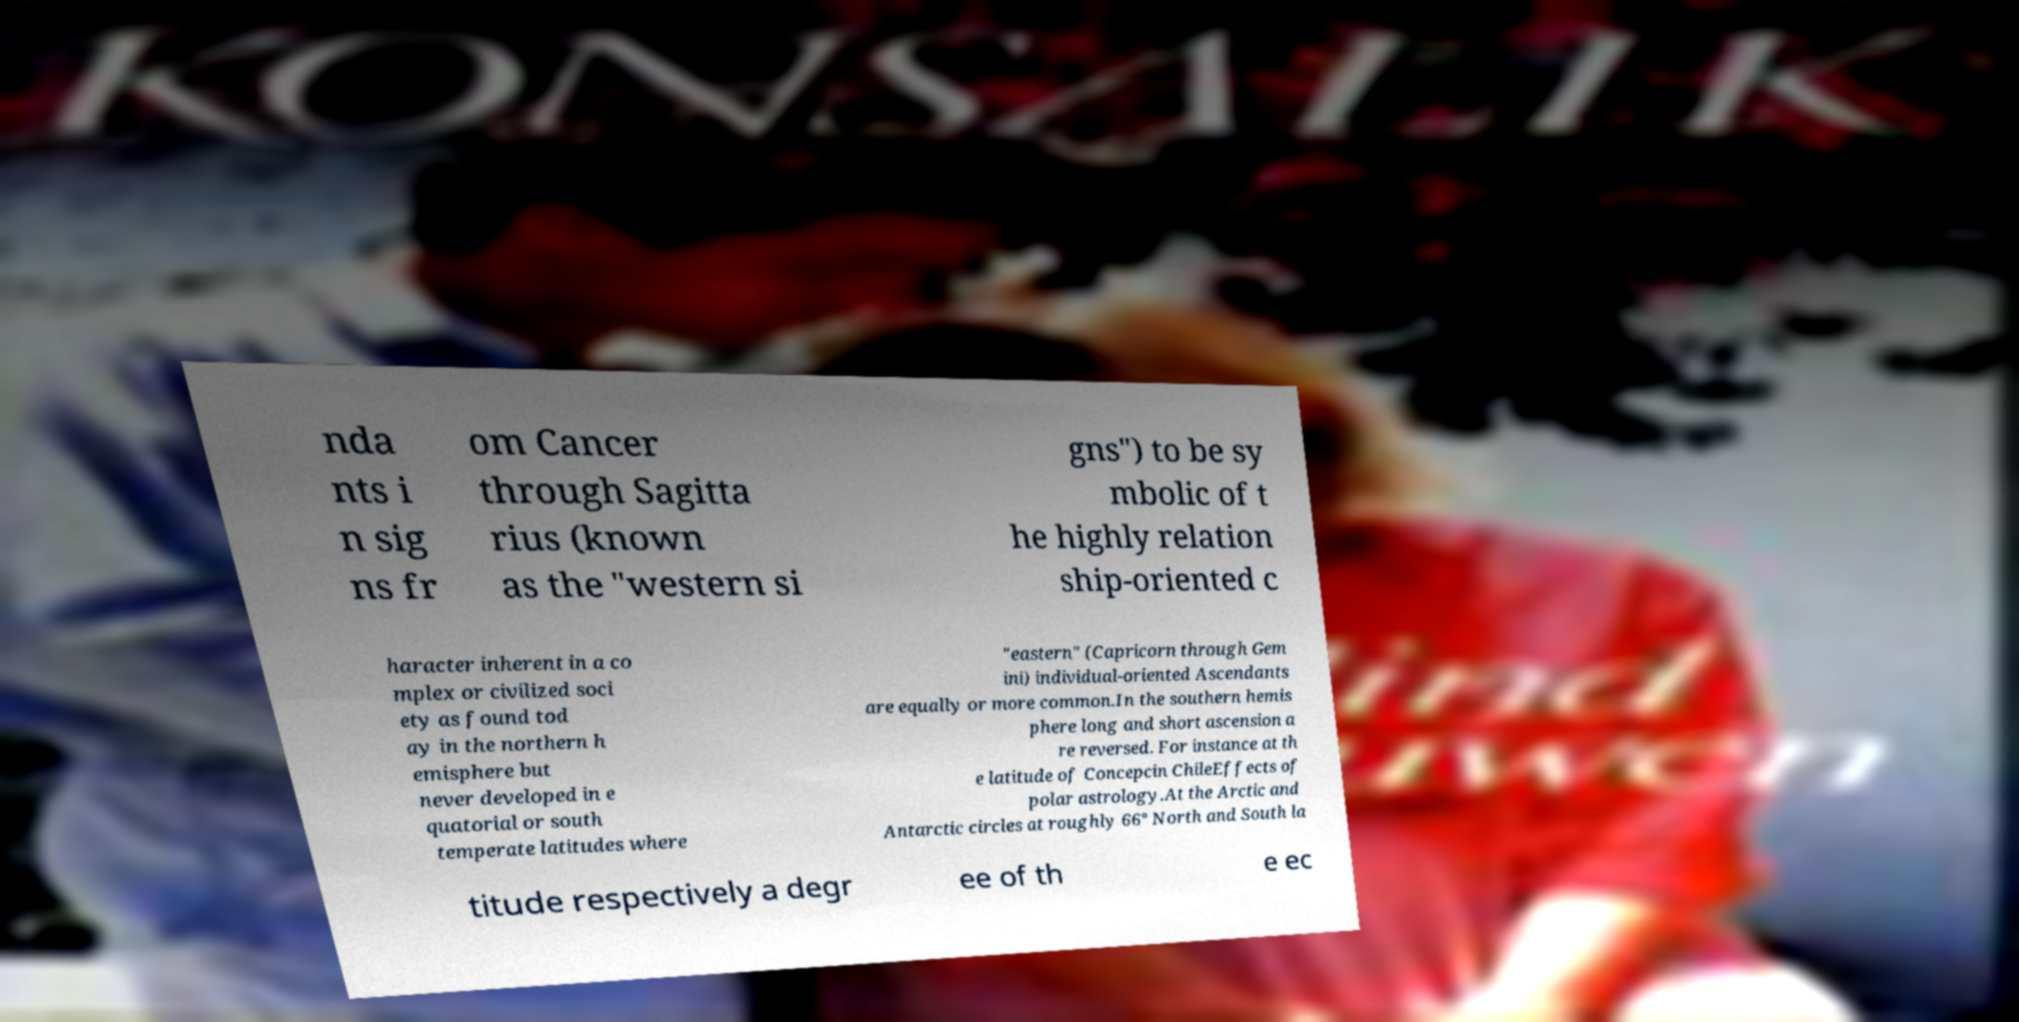Could you extract and type out the text from this image? nda nts i n sig ns fr om Cancer through Sagitta rius (known as the "western si gns") to be sy mbolic of t he highly relation ship-oriented c haracter inherent in a co mplex or civilized soci ety as found tod ay in the northern h emisphere but never developed in e quatorial or south temperate latitudes where "eastern" (Capricorn through Gem ini) individual-oriented Ascendants are equally or more common.In the southern hemis phere long and short ascension a re reversed. For instance at th e latitude of Concepcin ChileEffects of polar astrology.At the Arctic and Antarctic circles at roughly 66° North and South la titude respectively a degr ee of th e ec 